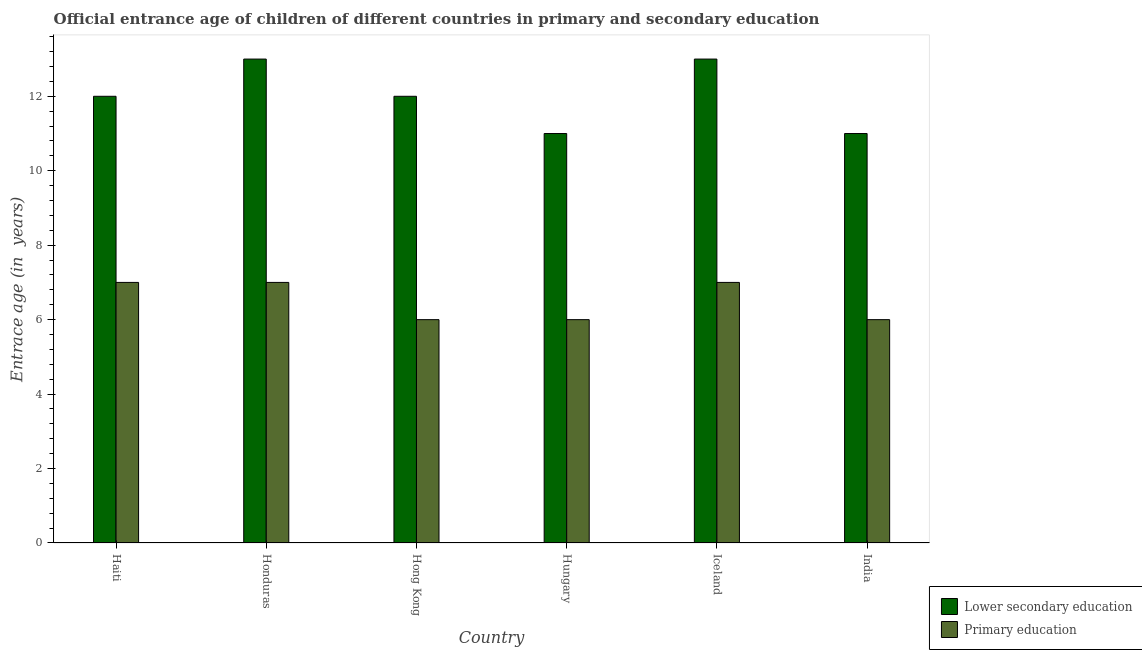How many groups of bars are there?
Offer a terse response. 6. Are the number of bars per tick equal to the number of legend labels?
Offer a very short reply. Yes. What is the label of the 3rd group of bars from the left?
Offer a very short reply. Hong Kong. In how many cases, is the number of bars for a given country not equal to the number of legend labels?
Keep it short and to the point. 0. What is the entrance age of chiildren in primary education in Honduras?
Ensure brevity in your answer.  7. Across all countries, what is the maximum entrance age of children in lower secondary education?
Provide a succinct answer. 13. In which country was the entrance age of children in lower secondary education maximum?
Your response must be concise. Honduras. In which country was the entrance age of children in lower secondary education minimum?
Keep it short and to the point. Hungary. What is the total entrance age of chiildren in primary education in the graph?
Ensure brevity in your answer.  39. What is the difference between the entrance age of children in lower secondary education in Haiti and that in Iceland?
Your answer should be very brief. -1. What is the difference between the entrance age of chiildren in primary education in Haiti and the entrance age of children in lower secondary education in Hong Kong?
Ensure brevity in your answer.  -5. What is the difference between the entrance age of chiildren in primary education and entrance age of children in lower secondary education in Hungary?
Offer a terse response. -5. In how many countries, is the entrance age of chiildren in primary education greater than 7.6 years?
Your answer should be compact. 0. What is the ratio of the entrance age of children in lower secondary education in Haiti to that in Iceland?
Your answer should be compact. 0.92. Is the difference between the entrance age of chiildren in primary education in Haiti and Honduras greater than the difference between the entrance age of children in lower secondary education in Haiti and Honduras?
Give a very brief answer. Yes. What is the difference between the highest and the second highest entrance age of children in lower secondary education?
Give a very brief answer. 0. What is the difference between the highest and the lowest entrance age of chiildren in primary education?
Your answer should be compact. 1. What does the 1st bar from the left in Haiti represents?
Offer a terse response. Lower secondary education. What does the 1st bar from the right in Honduras represents?
Your answer should be very brief. Primary education. What is the difference between two consecutive major ticks on the Y-axis?
Provide a succinct answer. 2. Are the values on the major ticks of Y-axis written in scientific E-notation?
Your response must be concise. No. Does the graph contain grids?
Your answer should be compact. No. Where does the legend appear in the graph?
Give a very brief answer. Bottom right. How are the legend labels stacked?
Provide a short and direct response. Vertical. What is the title of the graph?
Offer a terse response. Official entrance age of children of different countries in primary and secondary education. What is the label or title of the X-axis?
Offer a terse response. Country. What is the label or title of the Y-axis?
Your answer should be compact. Entrace age (in  years). What is the Entrace age (in  years) in Primary education in Haiti?
Ensure brevity in your answer.  7. What is the Entrace age (in  years) of Primary education in Honduras?
Give a very brief answer. 7. What is the Entrace age (in  years) in Lower secondary education in Hong Kong?
Provide a succinct answer. 12. What is the Entrace age (in  years) of Lower secondary education in India?
Provide a succinct answer. 11. What is the Entrace age (in  years) in Primary education in India?
Offer a terse response. 6. Across all countries, what is the maximum Entrace age (in  years) of Primary education?
Offer a terse response. 7. Across all countries, what is the minimum Entrace age (in  years) of Primary education?
Offer a very short reply. 6. What is the total Entrace age (in  years) of Primary education in the graph?
Make the answer very short. 39. What is the difference between the Entrace age (in  years) in Lower secondary education in Haiti and that in Honduras?
Give a very brief answer. -1. What is the difference between the Entrace age (in  years) in Lower secondary education in Haiti and that in Hong Kong?
Provide a succinct answer. 0. What is the difference between the Entrace age (in  years) of Primary education in Haiti and that in Hong Kong?
Provide a short and direct response. 1. What is the difference between the Entrace age (in  years) of Lower secondary education in Haiti and that in Hungary?
Keep it short and to the point. 1. What is the difference between the Entrace age (in  years) in Primary education in Haiti and that in Hungary?
Your response must be concise. 1. What is the difference between the Entrace age (in  years) of Lower secondary education in Haiti and that in Iceland?
Make the answer very short. -1. What is the difference between the Entrace age (in  years) of Primary education in Haiti and that in India?
Provide a short and direct response. 1. What is the difference between the Entrace age (in  years) of Lower secondary education in Honduras and that in Iceland?
Provide a succinct answer. 0. What is the difference between the Entrace age (in  years) in Primary education in Honduras and that in Iceland?
Offer a terse response. 0. What is the difference between the Entrace age (in  years) in Lower secondary education in Honduras and that in India?
Offer a very short reply. 2. What is the difference between the Entrace age (in  years) of Primary education in Hong Kong and that in Hungary?
Make the answer very short. 0. What is the difference between the Entrace age (in  years) in Lower secondary education in Hong Kong and that in Iceland?
Your response must be concise. -1. What is the difference between the Entrace age (in  years) of Primary education in Hong Kong and that in Iceland?
Ensure brevity in your answer.  -1. What is the difference between the Entrace age (in  years) in Lower secondary education in Hong Kong and that in India?
Make the answer very short. 1. What is the difference between the Entrace age (in  years) of Primary education in Hong Kong and that in India?
Provide a short and direct response. 0. What is the difference between the Entrace age (in  years) of Lower secondary education in Hungary and that in Iceland?
Offer a terse response. -2. What is the difference between the Entrace age (in  years) of Primary education in Hungary and that in Iceland?
Your answer should be very brief. -1. What is the difference between the Entrace age (in  years) of Lower secondary education in Hungary and that in India?
Make the answer very short. 0. What is the difference between the Entrace age (in  years) in Lower secondary education in Haiti and the Entrace age (in  years) in Primary education in Honduras?
Provide a short and direct response. 5. What is the difference between the Entrace age (in  years) in Lower secondary education in Haiti and the Entrace age (in  years) in Primary education in Hungary?
Your answer should be compact. 6. What is the difference between the Entrace age (in  years) of Lower secondary education in Haiti and the Entrace age (in  years) of Primary education in Iceland?
Your response must be concise. 5. What is the difference between the Entrace age (in  years) in Lower secondary education in Honduras and the Entrace age (in  years) in Primary education in Hong Kong?
Make the answer very short. 7. What is the difference between the Entrace age (in  years) in Lower secondary education in Honduras and the Entrace age (in  years) in Primary education in Iceland?
Offer a very short reply. 6. What is the difference between the Entrace age (in  years) of Lower secondary education in Honduras and the Entrace age (in  years) of Primary education in India?
Keep it short and to the point. 7. What is the difference between the Entrace age (in  years) of Lower secondary education in Hong Kong and the Entrace age (in  years) of Primary education in Hungary?
Provide a short and direct response. 6. What is the difference between the Entrace age (in  years) in Lower secondary education in Hong Kong and the Entrace age (in  years) in Primary education in India?
Give a very brief answer. 6. What is the difference between the Entrace age (in  years) of Lower secondary education in Hungary and the Entrace age (in  years) of Primary education in Iceland?
Give a very brief answer. 4. What is the difference between the Entrace age (in  years) in Lower secondary education in Iceland and the Entrace age (in  years) in Primary education in India?
Your answer should be very brief. 7. What is the average Entrace age (in  years) of Lower secondary education per country?
Give a very brief answer. 12. What is the difference between the Entrace age (in  years) in Lower secondary education and Entrace age (in  years) in Primary education in Haiti?
Offer a very short reply. 5. What is the difference between the Entrace age (in  years) in Lower secondary education and Entrace age (in  years) in Primary education in Hungary?
Offer a terse response. 5. What is the difference between the Entrace age (in  years) of Lower secondary education and Entrace age (in  years) of Primary education in Iceland?
Make the answer very short. 6. What is the ratio of the Entrace age (in  years) in Primary education in Haiti to that in Honduras?
Offer a terse response. 1. What is the ratio of the Entrace age (in  years) of Lower secondary education in Haiti to that in Hong Kong?
Your answer should be compact. 1. What is the ratio of the Entrace age (in  years) in Primary education in Haiti to that in Hong Kong?
Provide a succinct answer. 1.17. What is the ratio of the Entrace age (in  years) of Lower secondary education in Haiti to that in Hungary?
Make the answer very short. 1.09. What is the ratio of the Entrace age (in  years) of Primary education in Haiti to that in Hungary?
Provide a succinct answer. 1.17. What is the ratio of the Entrace age (in  years) in Primary education in Haiti to that in Iceland?
Your answer should be compact. 1. What is the ratio of the Entrace age (in  years) in Primary education in Haiti to that in India?
Offer a terse response. 1.17. What is the ratio of the Entrace age (in  years) of Lower secondary education in Honduras to that in Hong Kong?
Your answer should be very brief. 1.08. What is the ratio of the Entrace age (in  years) in Primary education in Honduras to that in Hong Kong?
Give a very brief answer. 1.17. What is the ratio of the Entrace age (in  years) of Lower secondary education in Honduras to that in Hungary?
Ensure brevity in your answer.  1.18. What is the ratio of the Entrace age (in  years) of Primary education in Honduras to that in Hungary?
Make the answer very short. 1.17. What is the ratio of the Entrace age (in  years) of Lower secondary education in Honduras to that in India?
Offer a terse response. 1.18. What is the ratio of the Entrace age (in  years) of Primary education in Honduras to that in India?
Your answer should be very brief. 1.17. What is the ratio of the Entrace age (in  years) in Lower secondary education in Hong Kong to that in Hungary?
Offer a very short reply. 1.09. What is the ratio of the Entrace age (in  years) of Lower secondary education in Hong Kong to that in India?
Provide a short and direct response. 1.09. What is the ratio of the Entrace age (in  years) in Lower secondary education in Hungary to that in Iceland?
Make the answer very short. 0.85. What is the ratio of the Entrace age (in  years) of Primary education in Hungary to that in Iceland?
Provide a short and direct response. 0.86. What is the ratio of the Entrace age (in  years) in Lower secondary education in Iceland to that in India?
Ensure brevity in your answer.  1.18. What is the difference between the highest and the second highest Entrace age (in  years) of Lower secondary education?
Your answer should be compact. 0. 